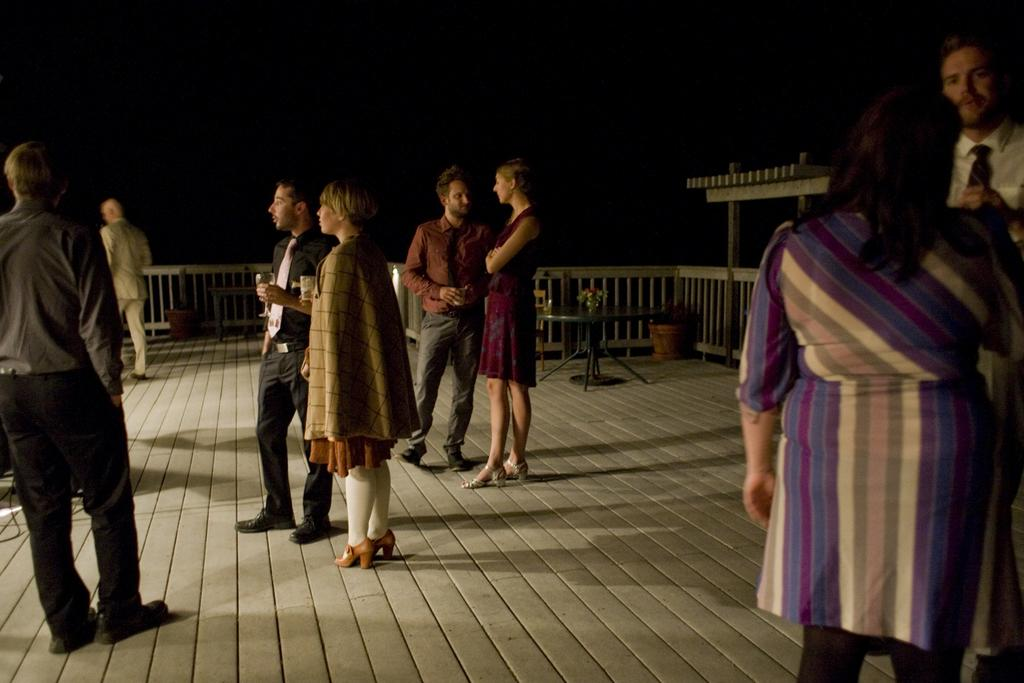What are the people in the image doing? The people in the image are standing and holding glasses in their hands. What can be seen in the background of the image? There is a table and flower pots in the background of the image. What type of bears can be seen in the image? There are no bears present in the image. Is there a picture hanging on the wall in the image? The provided facts do not mention a picture hanging on the wall, so we cannot definitively answer that question. --- Facts: 1. There is a car in the image. 2. The car is parked on the street. 3. There are trees on both sides of the street. 4. The sky is visible in the image. Absurd Topics: parrot, ocean, bicycle Conversation: What is the main subject of the image? The main subject of the image is a car. Where is the car located in the image? The car is parked on the street. What can be seen on both sides of the street in the image? There are trees on both sides of the street. What is visible in the background of the image? The sky is visible in the image. Reasoning: Let's think step by step in order to produce the conversation. We start by identifying the main subject in the image, which is the car. Then, we describe the location of the car, which is parked on the street. Next, we expand the conversation to include other items that are also visible, such as the trees on both sides of the street and the sky in the background. Each question is designed to elicit a specific detail about the image that is known from the provided facts. Absurd Question/Answer: Can you tell me how many parrots are sitting on the car in the image? There are no parrots present in the image. Is there an ocean visible in the background of the image? The provided facts do not mention an ocean, so we cannot definitively answer that question. --- Facts: 1. There is a person sitting on a bench in the image. 2. The person is reading a book. 3. There is a tree behind the bench. 4. The sky is visible in the image. Absurd Topics: elephant, painting, mountain Conversation: What is the person in the image doing? The person in the image is sitting on a bench and reading a book. What can be seen behind the bench in the image? There is a tree behind the bench. What is visible in the background of the image? The sky is visible in the image. Reasoning: Let's think step by step in order to produce the conversation. We start by identifying the main subject in the image, which is the person sitting on the bench. Then 